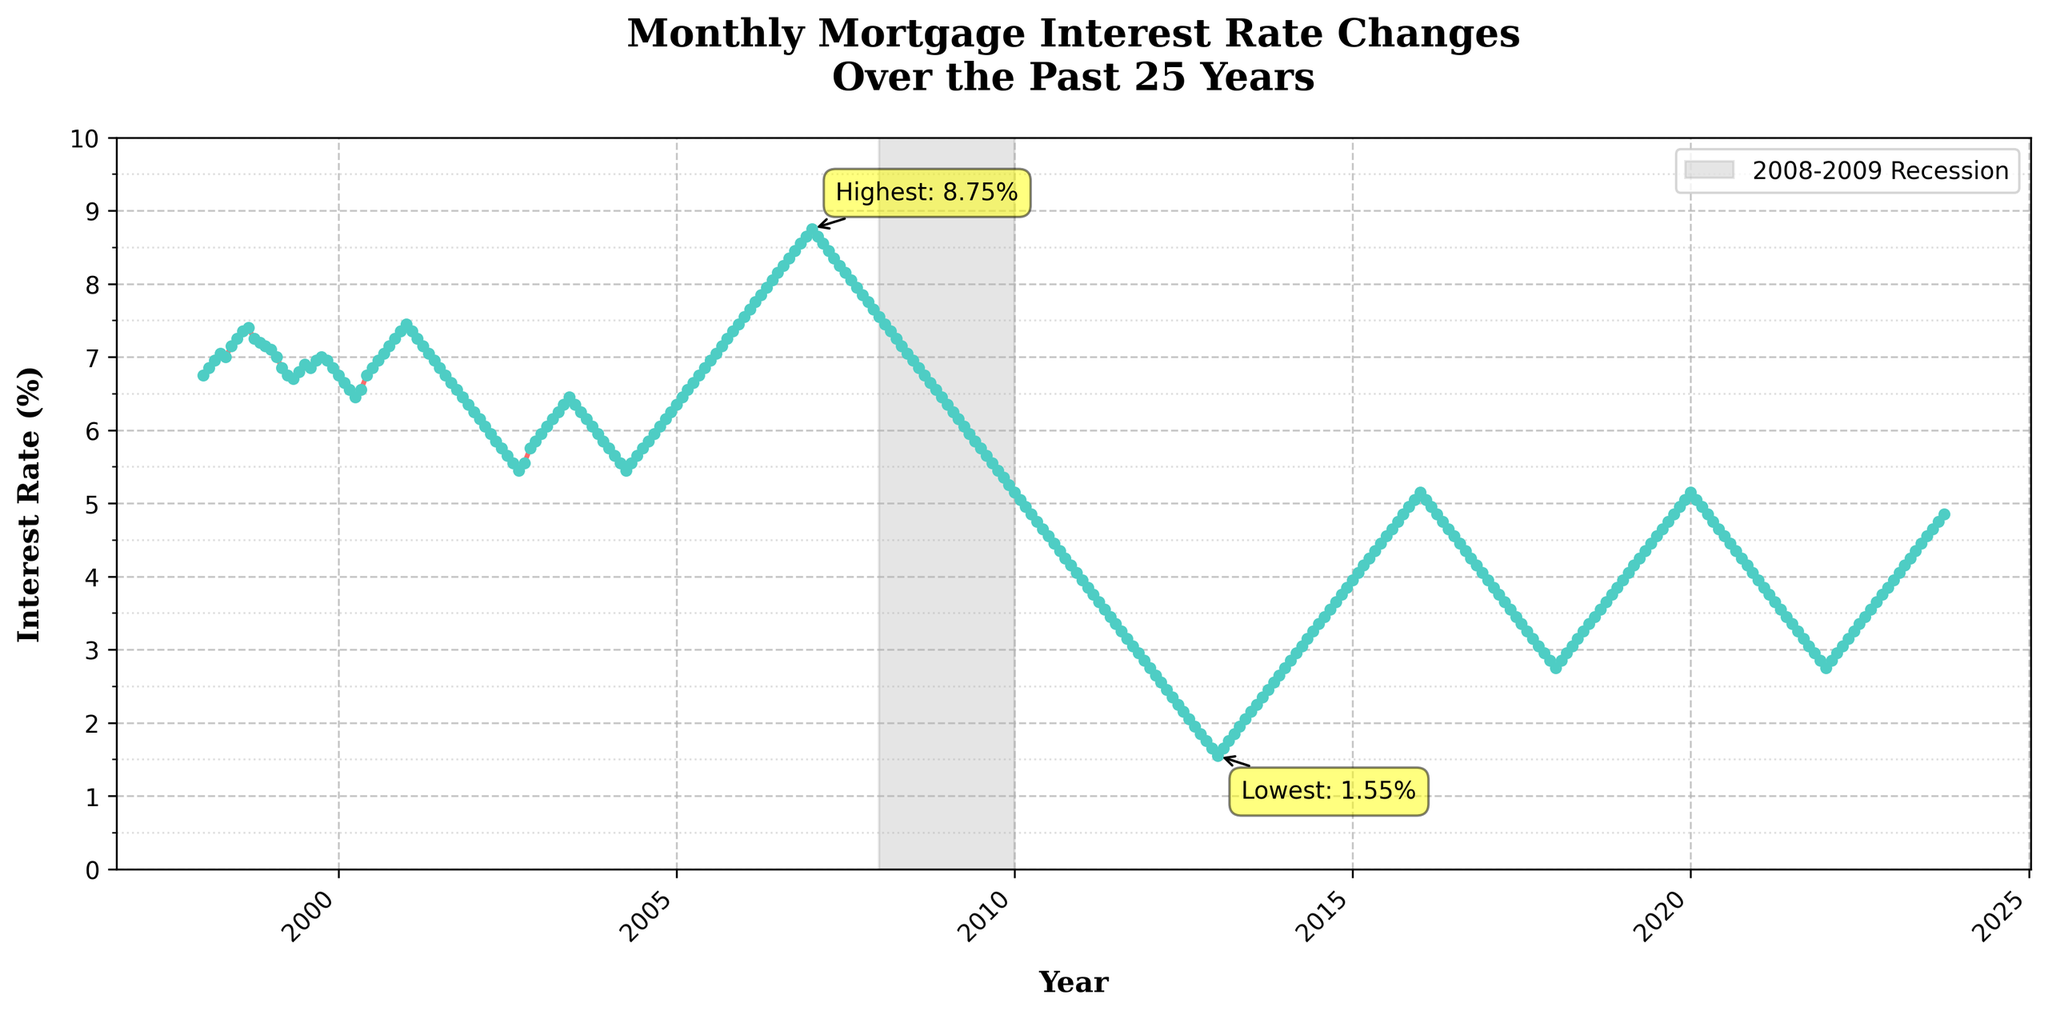How many recession periods are highlighted on the plot? The plot has one shaded area indicating the 2008-2009 recession period.
Answer: 1 What is the highest interest rate recorded, and when did it occur? The plot shows that the highest interest rate was 8.75% and it occurred in January 2007.
Answer: 8.75%, January 2007 What is the lowest interest rate recorded, and when did it occur? The plot shows that the lowest interest rate was 1.55% and it occurred in January 2013.
Answer: 1.55%, January 2013 How did the interest rate change between January 2008 and January 2009? Looking at the plot, the interest rate decreased from approximately 7.55% in January 2008 to 6.35% in January 2009.
Answer: Decreased by 1.20% What is the general trend of interest rates from 1998 to 2023? The plot shows that there was a peak in the early 2000s followed by a gradual decline until mid-2010s, then a slight increase towards 2023.
Answer: Decreasing then increasing Which year saw the largest drop in interest rates? Examine the steepest negative slope on the plot, which occurred between 2007 and 2008.
Answer: 2008 Compare the interest rate between the start and the end of the highlighted recession period. At the start of the recession period in 2008, the interest rate was about 7.55%, and it ended at 6.35% in 2009.
Answer: Decreased by 1.20% What were the interest rates in January 2000 and January 2010? Check the plot for the rates at these dates. January 2000 had about 6.75% and January 2010 had about 5.15%.
Answer: 6.75%, 5.15% How did the interest rate change from 2006 to 2008? From 2006, the interest rate was around 8.65%, and by 2008 it had dropped to around 7.55%.
Answer: Decreased by 1.10% Did the interest rate ever go below 2%? By examining the plot closely, we can see that the lowest point is slightly above 1.55% in January 2013 but never below 1.55%.
Answer: No 